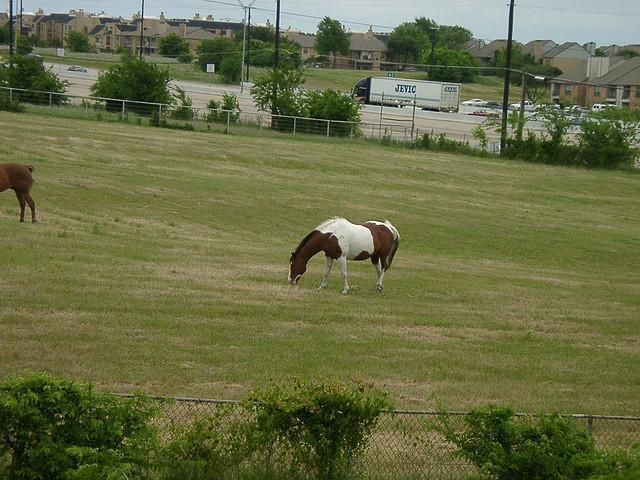How many horses are in the photo?
Give a very brief answer. 2. How many short horses do you see?
Give a very brief answer. 1. How many animals are there?
Give a very brief answer. 2. How many people are there?
Give a very brief answer. 0. 